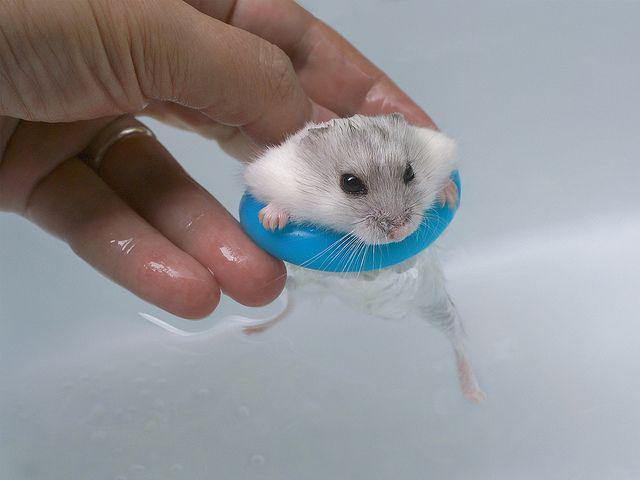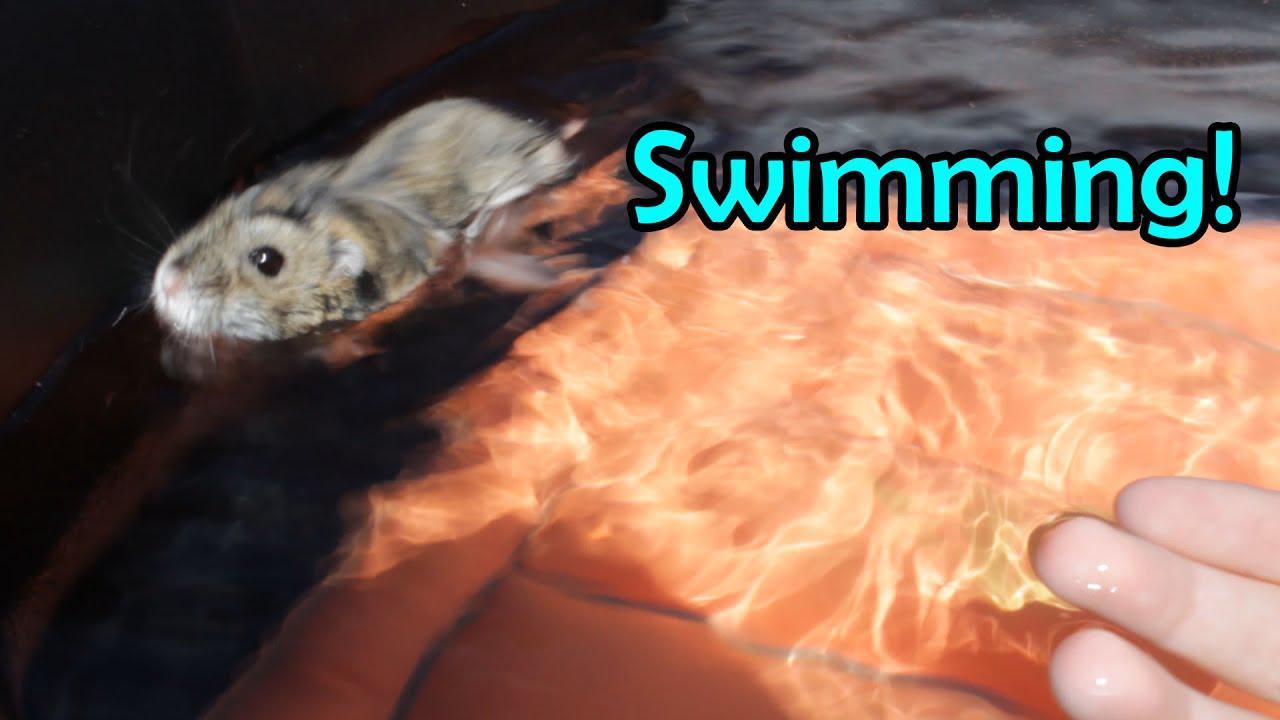The first image is the image on the left, the second image is the image on the right. Assess this claim about the two images: "in the right side image, there is a human hand holding the animal". Correct or not? Answer yes or no. No. The first image is the image on the left, the second image is the image on the right. Considering the images on both sides, is "There is a gerbil being held by a single human hand in one of the images." valid? Answer yes or no. Yes. 